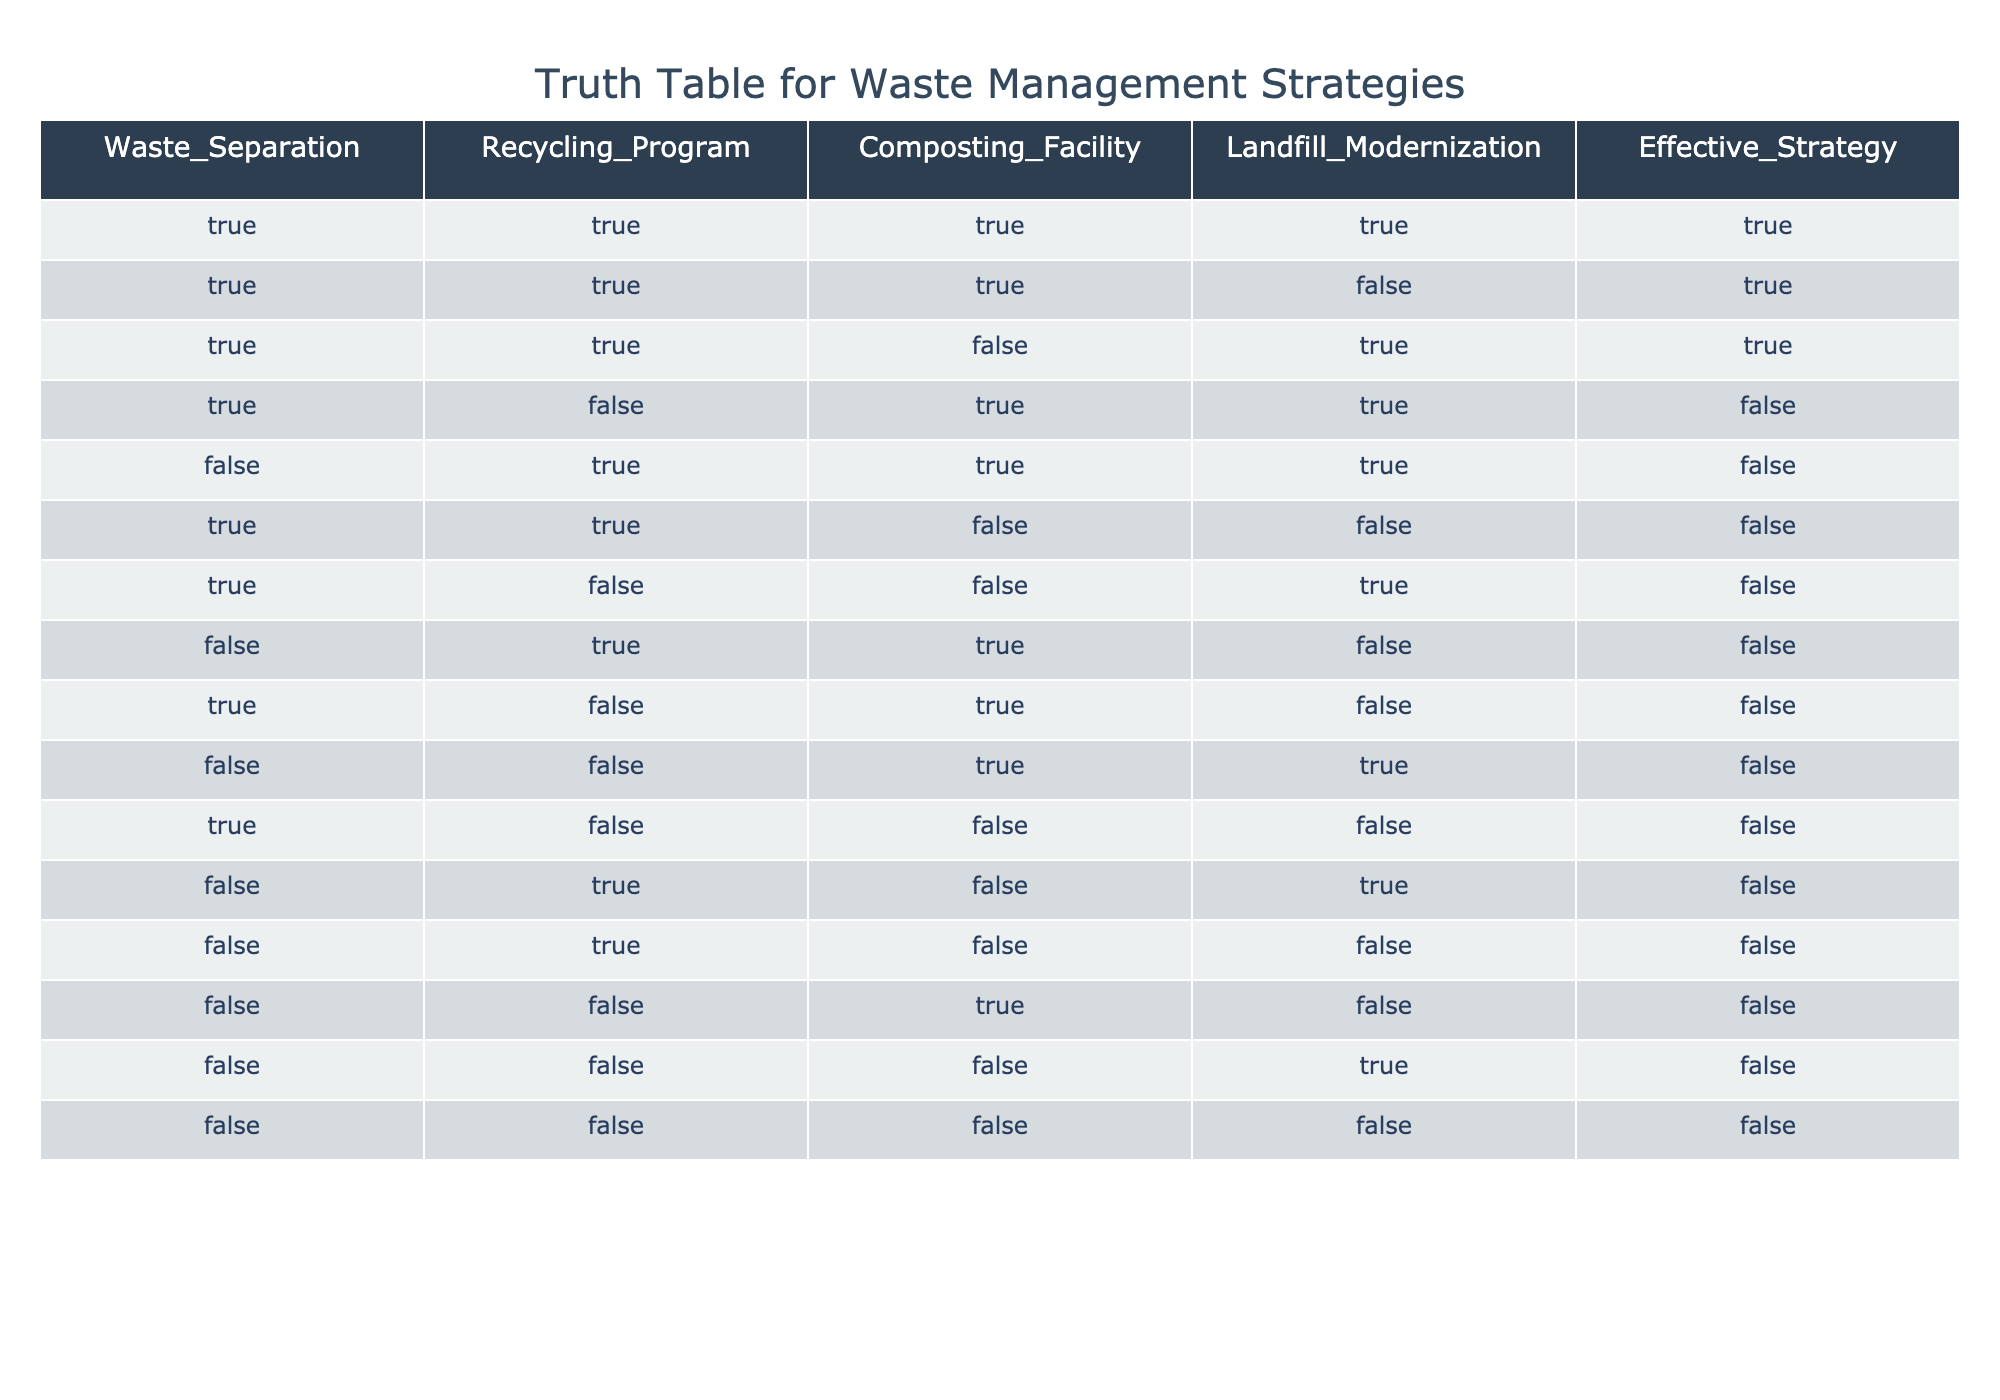What is the number of effective strategies when Waste Separation, Recycling Program, and Composting Facility are all true? There are 8 rows in the table. When Waste Separation, Recycling Program, and Composting Facility are all true, we find three rows where this condition is met: rows 1, 2, and 3. Therefore, the number of effective strategies is 3.
Answer: 3 Is landfill modernization necessary for an effective strategy? The effective strategy column shows that there are instances (rows 1, 2, and 3) where landfill modernization can be true or false, but all cases are effective only when conditions for other columns (Waste Separation, Recycling Program, Composting Facility) are also true. Thus, landfill modernization is not necessary as the effective strategies can still be true without it (e.g., row 2).
Answer: No How many total instances allow for an effective strategy with composting facilities true? We can count the rows where the composting facility is true: rows 1, 3, 4, 5, and 10. In these rows, we find 4 instances (rows 1, 3, and 5) where the effective strategy is true. Hence, the total instances that allow for an effective strategy with the composting facility true is 4.
Answer: 4 In how many scenarios is waste separation false and an effective strategy still true? Observing the table, rows where waste separation is false include rows 5, 10, 12, 13, 14, and 15. Among these, only row 10 shows an effective strategy as true. Therefore, there is only one scenario where waste separation is false, and the effective strategy remains true.
Answer: 1 What is the minimum number of strategies required to ensure an effective outcome? Analyzing the effective strategies in the table shows that there are some conditions where combinations of true values lead to effectiveness. The minimum combination that ensures efficacy is by keeping Waste Separation and Recycling Program both true, which leads to effective outcomes in both conditions regardless of other factors.
Answer: 2 